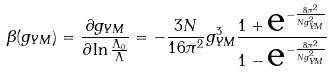Convert formula to latex. <formula><loc_0><loc_0><loc_500><loc_500>\beta ( g _ { Y M } ) = \frac { \partial g _ { Y M } } { \partial \ln \frac { \Lambda _ { 0 } } { \Lambda } } = - \frac { 3 N } { 1 6 \pi ^ { 2 } } g _ { Y M } ^ { 3 } \frac { 1 + { \mbox e } ^ { - \frac { 8 \pi ^ { 2 } } { N g _ { Y M } ^ { 2 } } } } { 1 - { \mbox e } ^ { - \frac { 8 \pi ^ { 2 } } { N g _ { Y M } ^ { 2 } } } }</formula> 